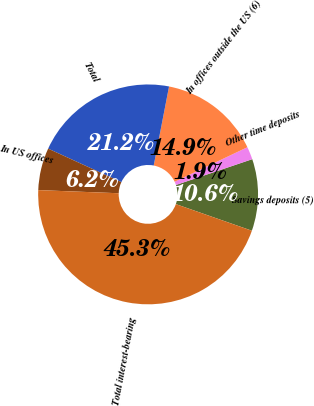<chart> <loc_0><loc_0><loc_500><loc_500><pie_chart><fcel>Savings deposits (5)<fcel>Other time deposits<fcel>In offices outside the US (6)<fcel>Total<fcel>In US offices<fcel>Total interest-bearing<nl><fcel>10.55%<fcel>1.87%<fcel>14.89%<fcel>21.22%<fcel>6.21%<fcel>45.26%<nl></chart> 